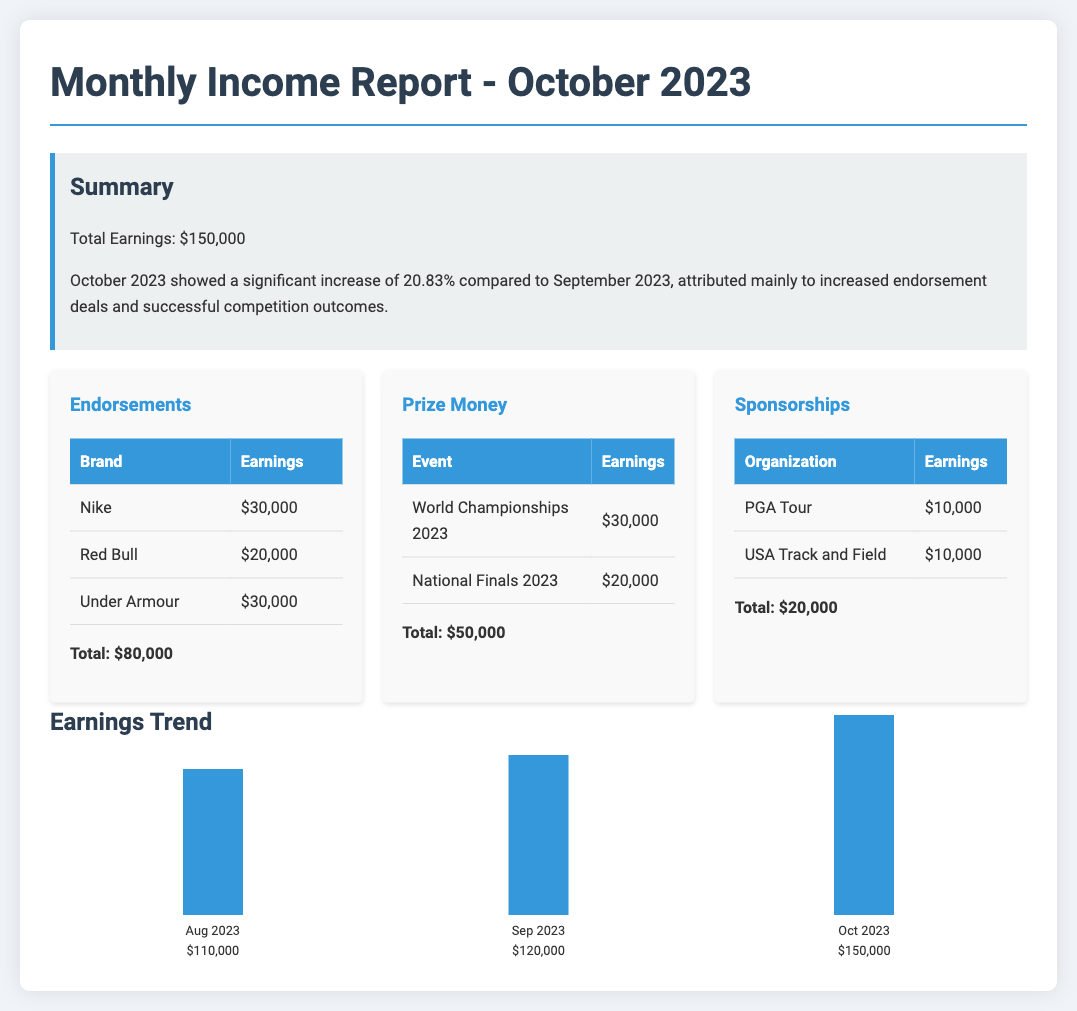What was the total earnings in October 2023? The total earnings for October 2023 is explicitly stated in the summary section of the document.
Answer: $150,000 What is the percentage increase in earnings compared to September 2023? The percentage increase is mentioned in the summary section, comparing October 2023 to the previous month.
Answer: 20.83% Which endorsement generated the highest earnings? The table for endorsements lists the earnings for each brand, allowing for comparison.
Answer: Nike How much was earned from prize money in total? The total earnings from prize money can be calculated by adding the amounts listed for individual events in the prize money section.
Answer: $50,000 Which brand is associated with the second highest earnings in endorsements? The endorsement table provides specific earnings associated with each brand, which helps in identifying rankings.
Answer: Red Bull What were the total earnings from sponsorships? The sponsorships section lists individual earnings, and the total can be found by summing these values.
Answer: $20,000 What was the total earnings for August 2023? The chart provides a visual representation of the earnings trend and includes the exact amount for August 2023.
Answer: $110,000 What event contributed the most to prize money this month? The prize money section specifies individual event contributions, allowing for identification of the highest.
Answer: World Championships 2023 Which organization is included in sponsorships earnings? The table in the sponsorship section lists the organizations with their respective earnings.
Answer: PGA Tour 